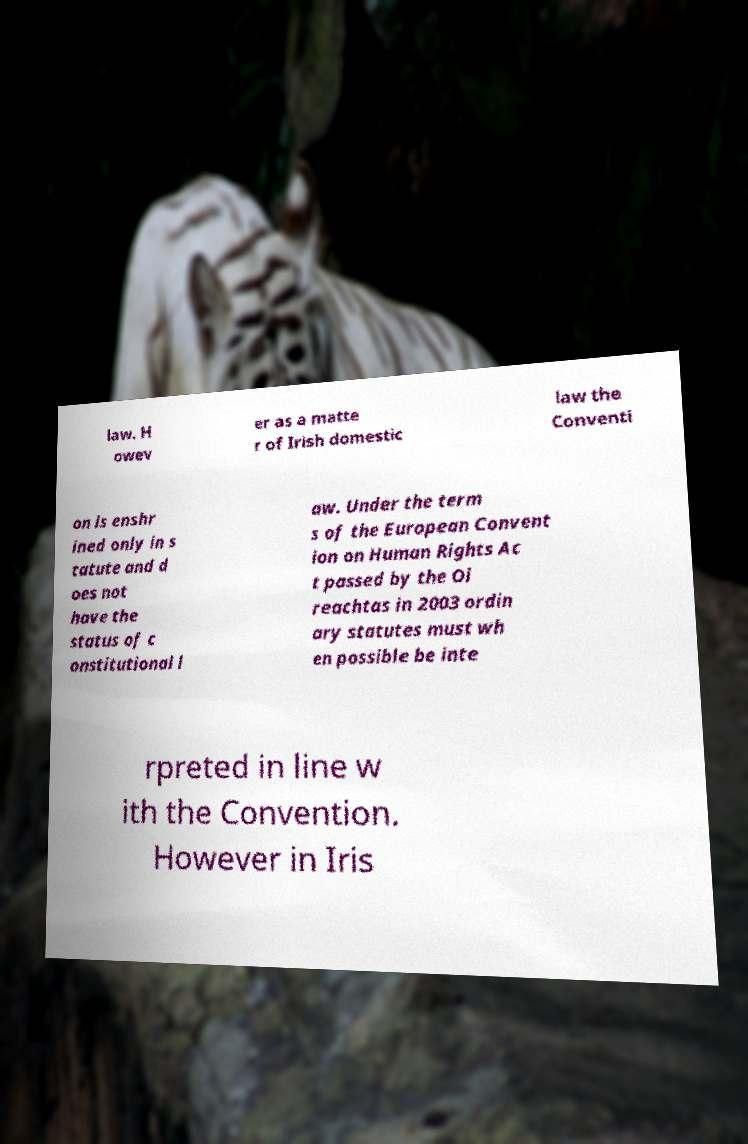What messages or text are displayed in this image? I need them in a readable, typed format. law. H owev er as a matte r of Irish domestic law the Conventi on is enshr ined only in s tatute and d oes not have the status of c onstitutional l aw. Under the term s of the European Convent ion on Human Rights Ac t passed by the Oi reachtas in 2003 ordin ary statutes must wh en possible be inte rpreted in line w ith the Convention. However in Iris 